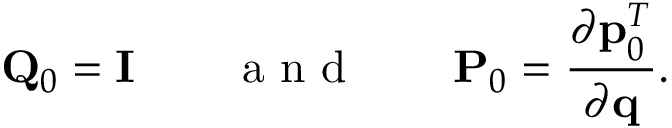<formula> <loc_0><loc_0><loc_500><loc_500>{ Q } _ { 0 } = { I } \quad a n d \quad { P } _ { 0 } = \frac { \partial { p } _ { 0 } ^ { T } } { \partial { q } } .</formula> 